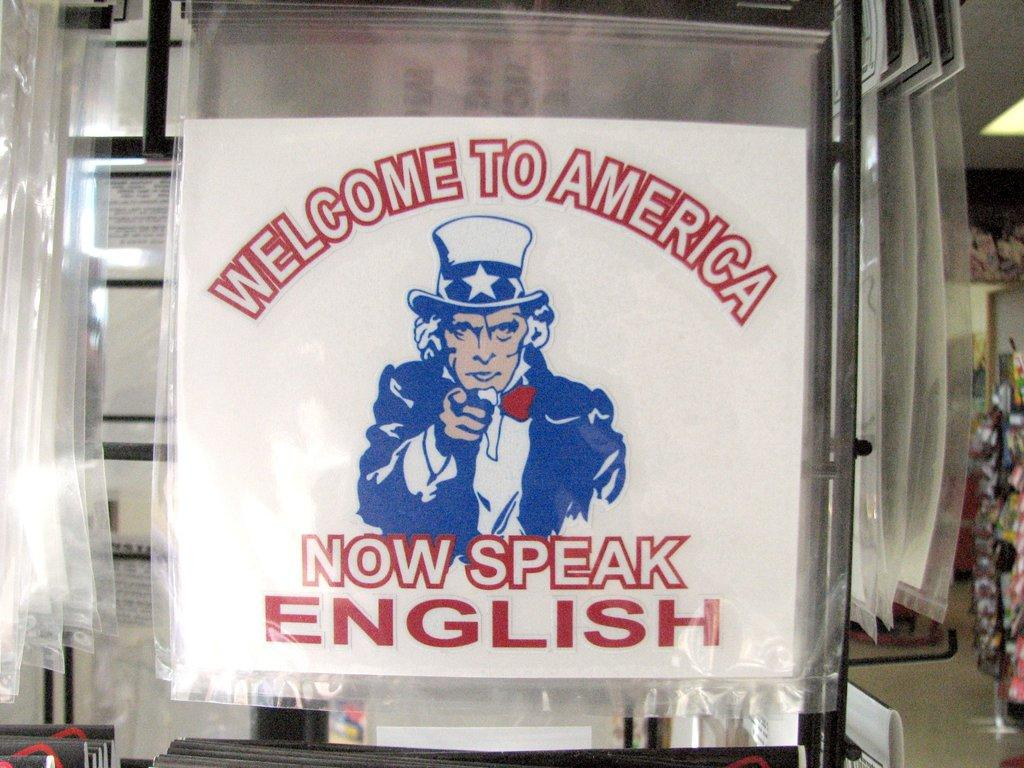Provide a one-sentence caption for the provided image. A poster reading Come to America telling people to speak English. 